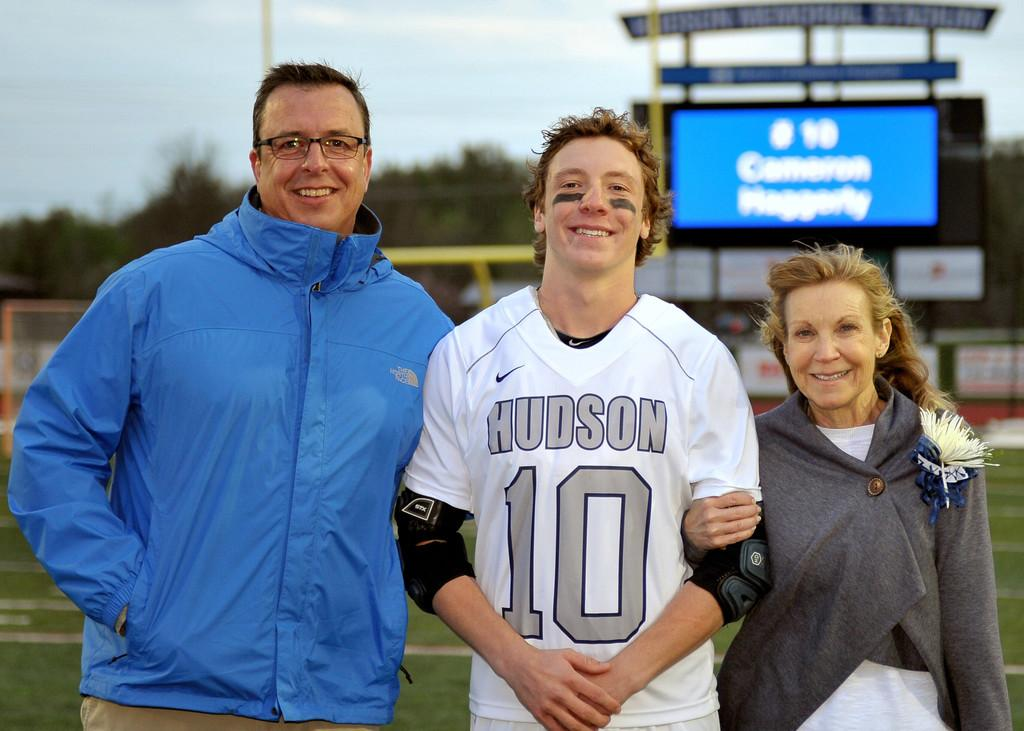<image>
Present a compact description of the photo's key features. a football players with his parents from hudson 